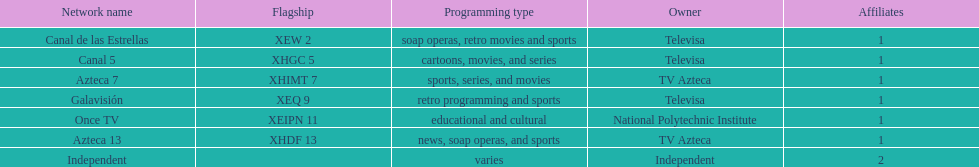What is the number of affiliates associated with galavision? 1. Can you parse all the data within this table? {'header': ['Network name', 'Flagship', 'Programming type', 'Owner', 'Affiliates'], 'rows': [['Canal de las Estrellas', 'XEW 2', 'soap operas, retro movies and sports', 'Televisa', '1'], ['Canal 5', 'XHGC 5', 'cartoons, movies, and series', 'Televisa', '1'], ['Azteca 7', 'XHIMT 7', 'sports, series, and movies', 'TV Azteca', '1'], ['Galavisión', 'XEQ 9', 'retro programming and sports', 'Televisa', '1'], ['Once TV', 'XEIPN 11', 'educational and cultural', 'National Polytechnic Institute', '1'], ['Azteca 13', 'XHDF 13', 'news, soap operas, and sports', 'TV Azteca', '1'], ['Independent', '', 'varies', 'Independent', '2']]} 